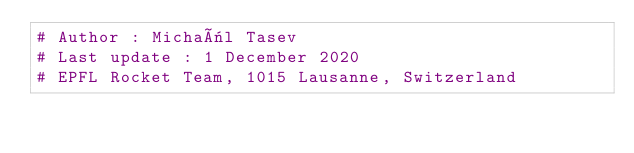<code> <loc_0><loc_0><loc_500><loc_500><_Python_># Author : Michaël Tasev
# Last update : 1 December 2020
# EPFL Rocket Team, 1015 Lausanne, Switzerland
</code> 